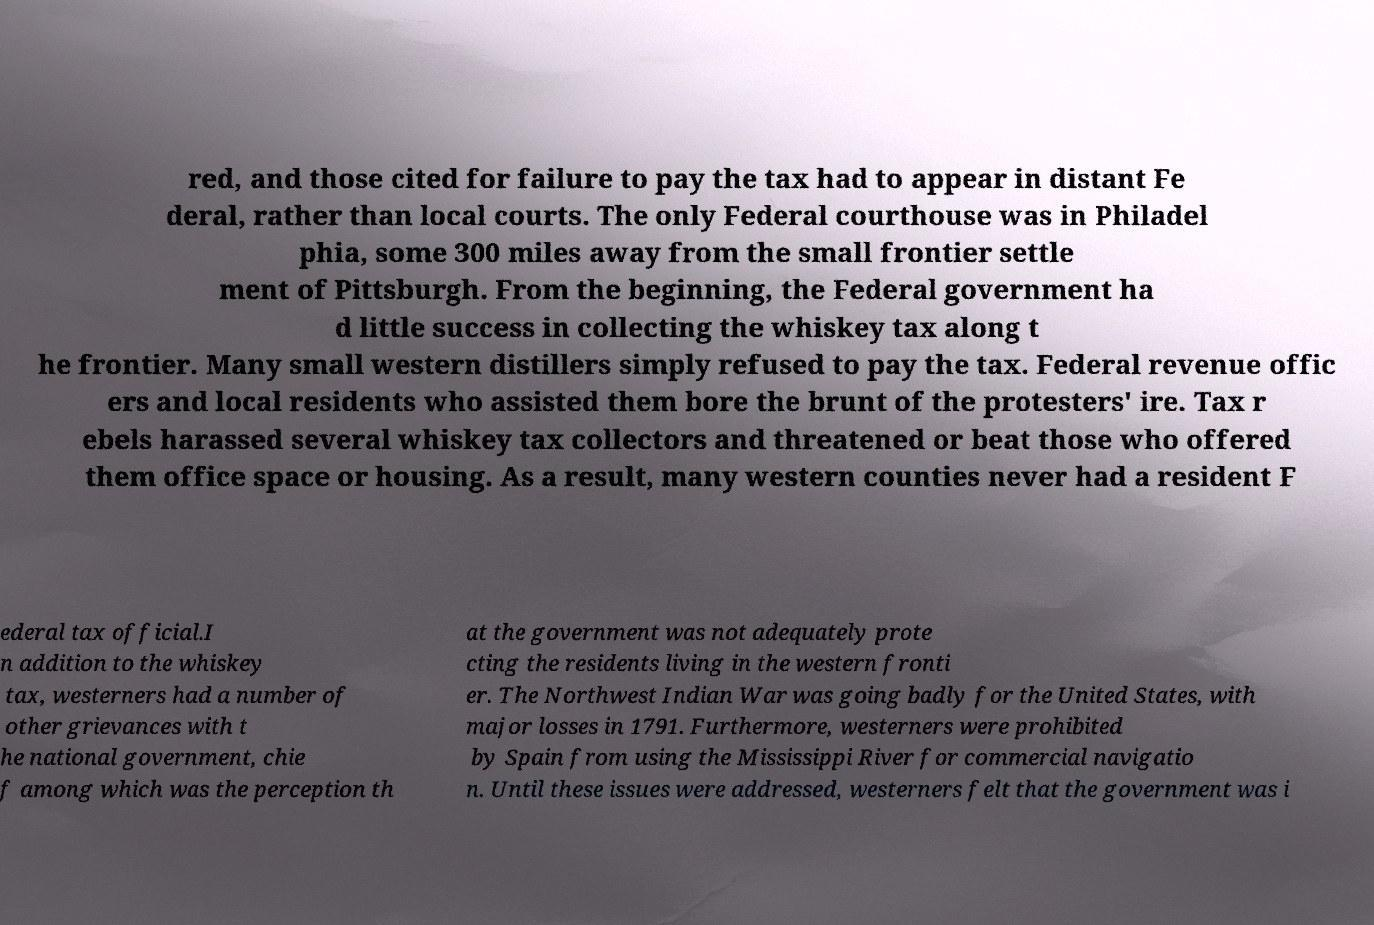Could you extract and type out the text from this image? red, and those cited for failure to pay the tax had to appear in distant Fe deral, rather than local courts. The only Federal courthouse was in Philadel phia, some 300 miles away from the small frontier settle ment of Pittsburgh. From the beginning, the Federal government ha d little success in collecting the whiskey tax along t he frontier. Many small western distillers simply refused to pay the tax. Federal revenue offic ers and local residents who assisted them bore the brunt of the protesters' ire. Tax r ebels harassed several whiskey tax collectors and threatened or beat those who offered them office space or housing. As a result, many western counties never had a resident F ederal tax official.I n addition to the whiskey tax, westerners had a number of other grievances with t he national government, chie f among which was the perception th at the government was not adequately prote cting the residents living in the western fronti er. The Northwest Indian War was going badly for the United States, with major losses in 1791. Furthermore, westerners were prohibited by Spain from using the Mississippi River for commercial navigatio n. Until these issues were addressed, westerners felt that the government was i 